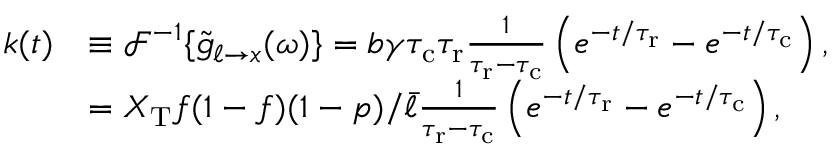Convert formula to latex. <formula><loc_0><loc_0><loc_500><loc_500>\begin{array} { r l } { k ( t ) } & { \equiv \mathcal { F } ^ { - 1 } \{ \tilde { g } _ { \ell \to x } ( \omega ) \} = b \gamma { \tau _ { c } } { \tau _ { r } } \frac { 1 } { { \tau _ { r } } - { \tau _ { c } } } \left ( e ^ { - t / { \tau _ { r } } } - e ^ { - t / { \tau _ { c } } } \right ) , } \\ & { = X _ { T } f ( 1 - f ) ( 1 - p ) / \bar { \ell } \frac { 1 } { { \tau _ { r } } - { \tau _ { c } } } \left ( e ^ { - t / { \tau _ { r } } } - e ^ { - t / { \tau _ { c } } } \right ) , } \end{array}</formula> 